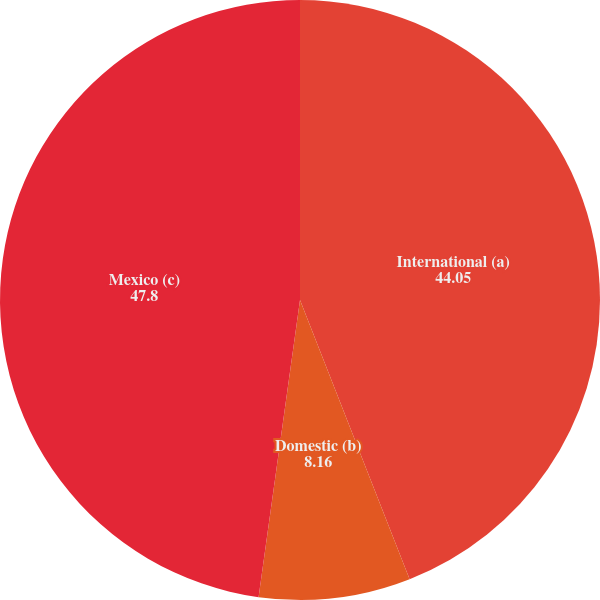Convert chart. <chart><loc_0><loc_0><loc_500><loc_500><pie_chart><fcel>International (a)<fcel>Domestic (b)<fcel>Mexico (c)<nl><fcel>44.05%<fcel>8.16%<fcel>47.8%<nl></chart> 